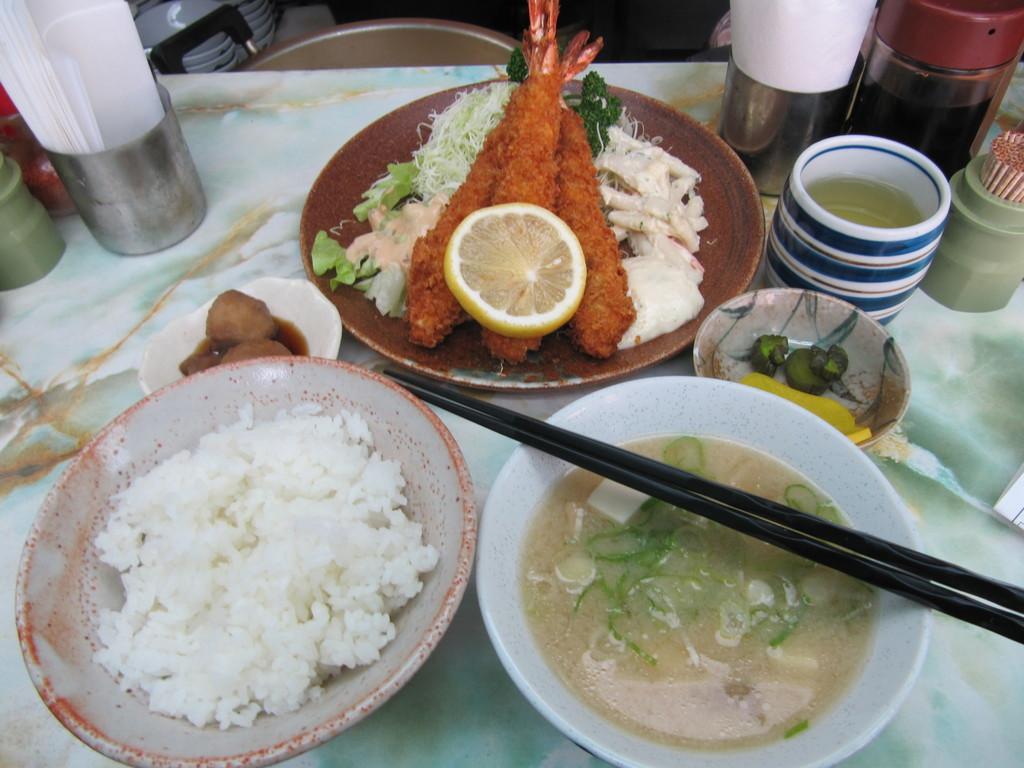What is the main object in the center of the image? There is a dining table in the center of the image. What can be found on the dining table? Food items, glasses, and tissues are present on the dining table. What type of collar can be seen on the snake in the image? There is no snake or collar present in the image. 